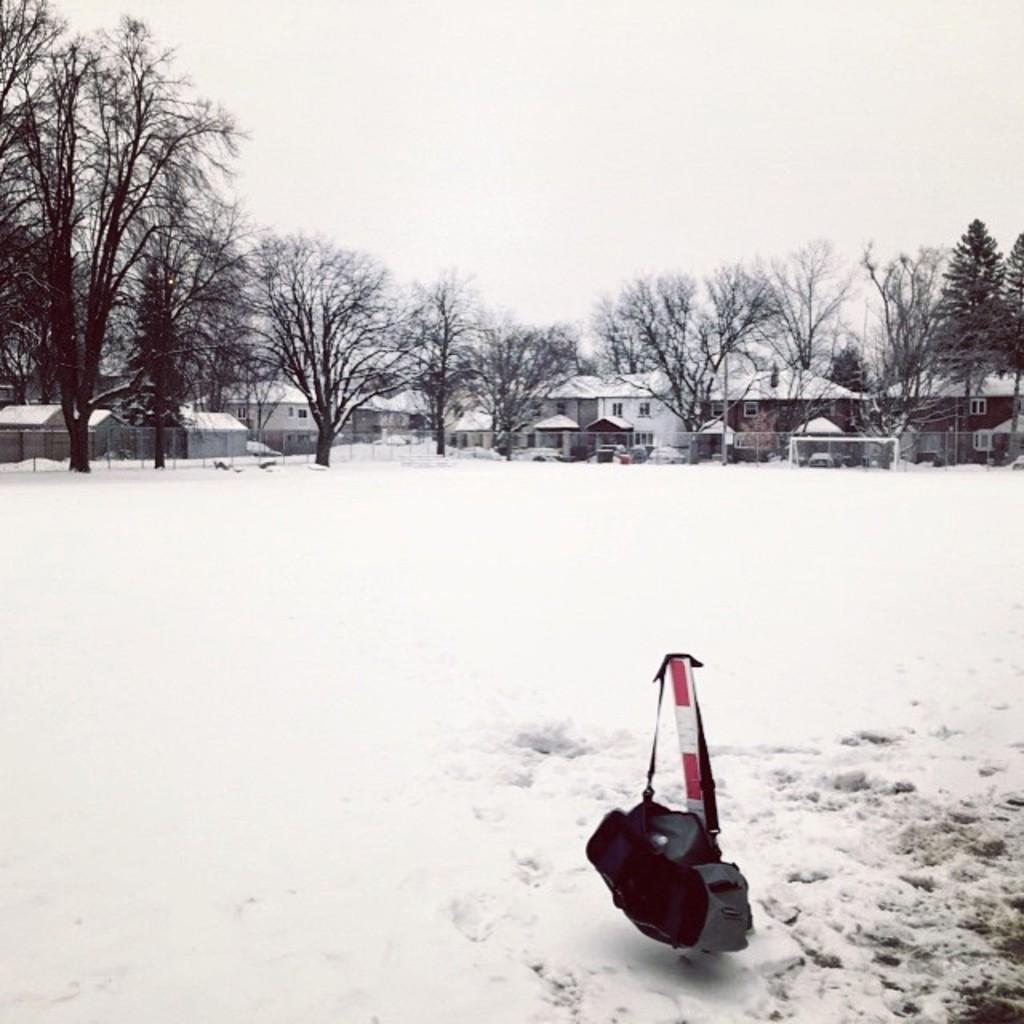Describe this image in one or two sentences. In this image there is a bag hanging on the road, there is snow on the surface. In the background there are trees, buildings and the sky. 